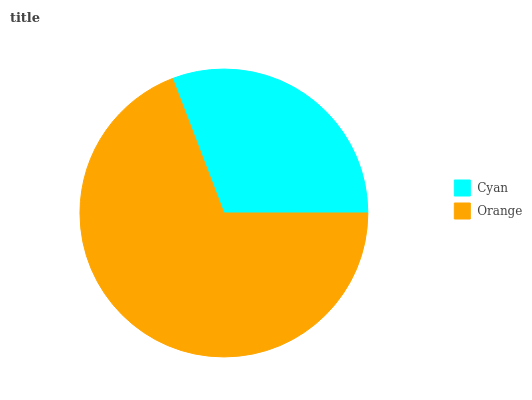Is Cyan the minimum?
Answer yes or no. Yes. Is Orange the maximum?
Answer yes or no. Yes. Is Orange the minimum?
Answer yes or no. No. Is Orange greater than Cyan?
Answer yes or no. Yes. Is Cyan less than Orange?
Answer yes or no. Yes. Is Cyan greater than Orange?
Answer yes or no. No. Is Orange less than Cyan?
Answer yes or no. No. Is Orange the high median?
Answer yes or no. Yes. Is Cyan the low median?
Answer yes or no. Yes. Is Cyan the high median?
Answer yes or no. No. Is Orange the low median?
Answer yes or no. No. 